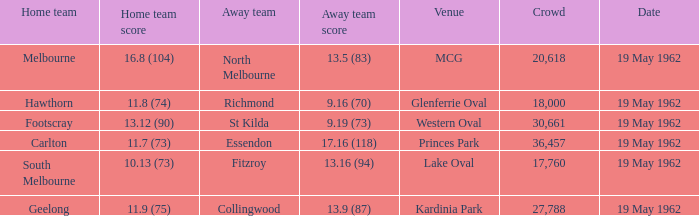What does the away team's score amount to when the home team achieves a score of 16.8 (104)? 13.5 (83). 